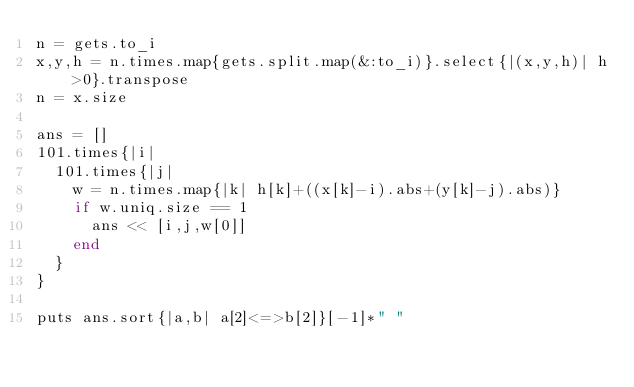Convert code to text. <code><loc_0><loc_0><loc_500><loc_500><_Ruby_>n = gets.to_i
x,y,h = n.times.map{gets.split.map(&:to_i)}.select{|(x,y,h)| h>0}.transpose
n = x.size

ans = []
101.times{|i|
  101.times{|j|
    w = n.times.map{|k| h[k]+((x[k]-i).abs+(y[k]-j).abs)}
    if w.uniq.size == 1
      ans << [i,j,w[0]]
    end
  }
}
 
puts ans.sort{|a,b| a[2]<=>b[2]}[-1]*" "</code> 